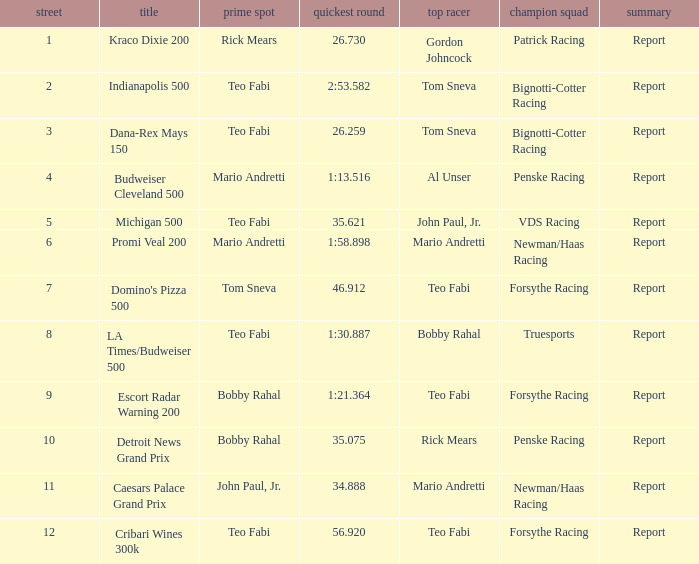Which Rd took place at the Indianapolis 500? 2.0. 